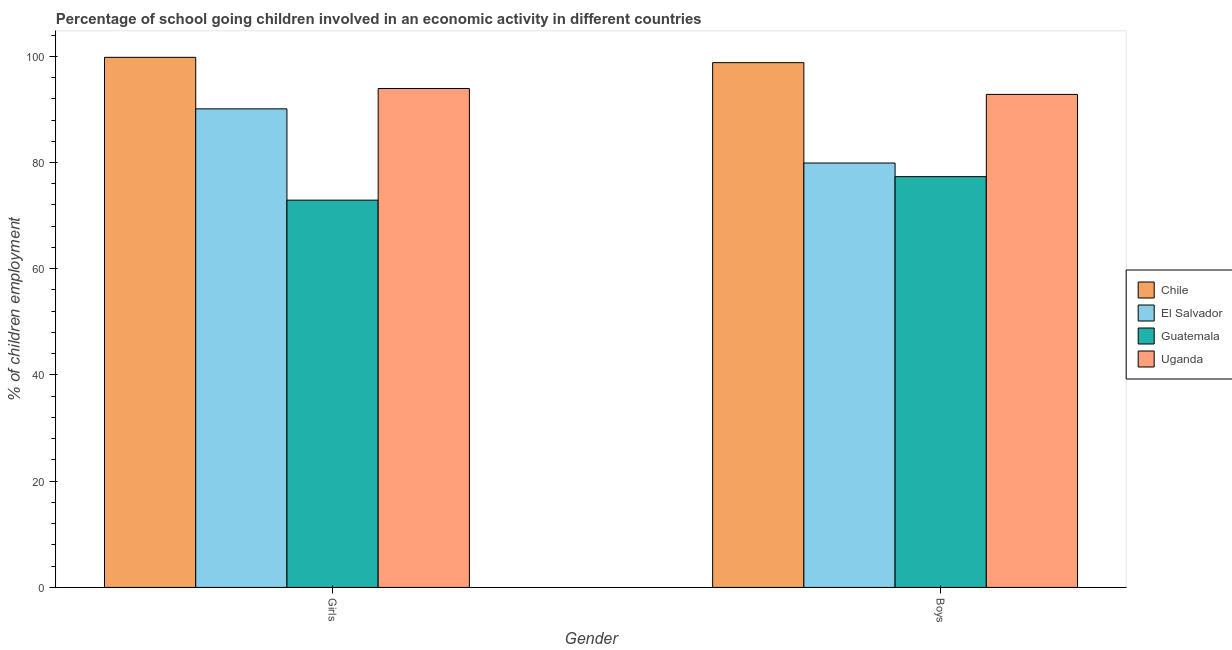How many different coloured bars are there?
Your answer should be compact. 4. How many groups of bars are there?
Make the answer very short. 2. How many bars are there on the 2nd tick from the left?
Keep it short and to the point. 4. How many bars are there on the 1st tick from the right?
Your answer should be compact. 4. What is the label of the 2nd group of bars from the left?
Ensure brevity in your answer.  Boys. What is the percentage of school going boys in El Salvador?
Make the answer very short. 79.9. Across all countries, what is the maximum percentage of school going girls?
Offer a terse response. 99.8. Across all countries, what is the minimum percentage of school going girls?
Give a very brief answer. 72.91. In which country was the percentage of school going girls minimum?
Provide a short and direct response. Guatemala. What is the total percentage of school going boys in the graph?
Provide a succinct answer. 348.86. What is the difference between the percentage of school going girls in Uganda and that in El Salvador?
Ensure brevity in your answer.  3.83. What is the difference between the percentage of school going boys in Uganda and the percentage of school going girls in El Salvador?
Keep it short and to the point. 2.72. What is the average percentage of school going girls per country?
Ensure brevity in your answer.  89.19. What is the difference between the percentage of school going boys and percentage of school going girls in El Salvador?
Make the answer very short. -10.2. In how many countries, is the percentage of school going boys greater than 12 %?
Offer a terse response. 4. What is the ratio of the percentage of school going boys in Guatemala to that in El Salvador?
Provide a short and direct response. 0.97. In how many countries, is the percentage of school going girls greater than the average percentage of school going girls taken over all countries?
Give a very brief answer. 3. What does the 1st bar from the right in Boys represents?
Your answer should be very brief. Uganda. Are all the bars in the graph horizontal?
Ensure brevity in your answer.  No. How many countries are there in the graph?
Keep it short and to the point. 4. Does the graph contain any zero values?
Keep it short and to the point. No. Does the graph contain grids?
Offer a terse response. No. Where does the legend appear in the graph?
Give a very brief answer. Center right. How many legend labels are there?
Offer a terse response. 4. What is the title of the graph?
Keep it short and to the point. Percentage of school going children involved in an economic activity in different countries. What is the label or title of the X-axis?
Give a very brief answer. Gender. What is the label or title of the Y-axis?
Provide a succinct answer. % of children employment. What is the % of children employment of Chile in Girls?
Offer a very short reply. 99.8. What is the % of children employment in El Salvador in Girls?
Provide a short and direct response. 90.1. What is the % of children employment of Guatemala in Girls?
Offer a terse response. 72.91. What is the % of children employment in Uganda in Girls?
Provide a succinct answer. 93.93. What is the % of children employment of Chile in Boys?
Offer a very short reply. 98.8. What is the % of children employment in El Salvador in Boys?
Your answer should be very brief. 79.9. What is the % of children employment in Guatemala in Boys?
Make the answer very short. 77.34. What is the % of children employment in Uganda in Boys?
Your response must be concise. 92.82. Across all Gender, what is the maximum % of children employment in Chile?
Provide a short and direct response. 99.8. Across all Gender, what is the maximum % of children employment of El Salvador?
Give a very brief answer. 90.1. Across all Gender, what is the maximum % of children employment of Guatemala?
Make the answer very short. 77.34. Across all Gender, what is the maximum % of children employment in Uganda?
Your answer should be very brief. 93.93. Across all Gender, what is the minimum % of children employment of Chile?
Ensure brevity in your answer.  98.8. Across all Gender, what is the minimum % of children employment in El Salvador?
Offer a terse response. 79.9. Across all Gender, what is the minimum % of children employment in Guatemala?
Offer a terse response. 72.91. Across all Gender, what is the minimum % of children employment of Uganda?
Give a very brief answer. 92.82. What is the total % of children employment of Chile in the graph?
Offer a very short reply. 198.6. What is the total % of children employment of El Salvador in the graph?
Give a very brief answer. 170. What is the total % of children employment of Guatemala in the graph?
Ensure brevity in your answer.  150.25. What is the total % of children employment in Uganda in the graph?
Ensure brevity in your answer.  186.75. What is the difference between the % of children employment of El Salvador in Girls and that in Boys?
Give a very brief answer. 10.2. What is the difference between the % of children employment of Guatemala in Girls and that in Boys?
Offer a very short reply. -4.43. What is the difference between the % of children employment in Uganda in Girls and that in Boys?
Keep it short and to the point. 1.11. What is the difference between the % of children employment in Chile in Girls and the % of children employment in El Salvador in Boys?
Offer a terse response. 19.9. What is the difference between the % of children employment of Chile in Girls and the % of children employment of Guatemala in Boys?
Provide a short and direct response. 22.46. What is the difference between the % of children employment in Chile in Girls and the % of children employment in Uganda in Boys?
Your answer should be compact. 6.98. What is the difference between the % of children employment of El Salvador in Girls and the % of children employment of Guatemala in Boys?
Keep it short and to the point. 12.76. What is the difference between the % of children employment in El Salvador in Girls and the % of children employment in Uganda in Boys?
Keep it short and to the point. -2.72. What is the difference between the % of children employment in Guatemala in Girls and the % of children employment in Uganda in Boys?
Give a very brief answer. -19.91. What is the average % of children employment of Chile per Gender?
Make the answer very short. 99.3. What is the average % of children employment in El Salvador per Gender?
Give a very brief answer. 85. What is the average % of children employment in Guatemala per Gender?
Give a very brief answer. 75.13. What is the average % of children employment in Uganda per Gender?
Ensure brevity in your answer.  93.37. What is the difference between the % of children employment of Chile and % of children employment of Guatemala in Girls?
Your answer should be compact. 26.89. What is the difference between the % of children employment in Chile and % of children employment in Uganda in Girls?
Provide a short and direct response. 5.87. What is the difference between the % of children employment of El Salvador and % of children employment of Guatemala in Girls?
Make the answer very short. 17.19. What is the difference between the % of children employment of El Salvador and % of children employment of Uganda in Girls?
Ensure brevity in your answer.  -3.83. What is the difference between the % of children employment in Guatemala and % of children employment in Uganda in Girls?
Provide a succinct answer. -21.02. What is the difference between the % of children employment in Chile and % of children employment in El Salvador in Boys?
Give a very brief answer. 18.9. What is the difference between the % of children employment of Chile and % of children employment of Guatemala in Boys?
Make the answer very short. 21.46. What is the difference between the % of children employment in Chile and % of children employment in Uganda in Boys?
Make the answer very short. 5.98. What is the difference between the % of children employment in El Salvador and % of children employment in Guatemala in Boys?
Make the answer very short. 2.56. What is the difference between the % of children employment in El Salvador and % of children employment in Uganda in Boys?
Ensure brevity in your answer.  -12.92. What is the difference between the % of children employment of Guatemala and % of children employment of Uganda in Boys?
Offer a terse response. -15.48. What is the ratio of the % of children employment of Chile in Girls to that in Boys?
Offer a terse response. 1.01. What is the ratio of the % of children employment of El Salvador in Girls to that in Boys?
Keep it short and to the point. 1.13. What is the ratio of the % of children employment of Guatemala in Girls to that in Boys?
Provide a succinct answer. 0.94. What is the ratio of the % of children employment of Uganda in Girls to that in Boys?
Offer a very short reply. 1.01. What is the difference between the highest and the second highest % of children employment in Chile?
Your response must be concise. 1. What is the difference between the highest and the second highest % of children employment in El Salvador?
Make the answer very short. 10.2. What is the difference between the highest and the second highest % of children employment in Guatemala?
Offer a very short reply. 4.43. What is the difference between the highest and the second highest % of children employment of Uganda?
Provide a short and direct response. 1.11. What is the difference between the highest and the lowest % of children employment of Chile?
Offer a terse response. 1. What is the difference between the highest and the lowest % of children employment in El Salvador?
Provide a short and direct response. 10.2. What is the difference between the highest and the lowest % of children employment of Guatemala?
Keep it short and to the point. 4.43. What is the difference between the highest and the lowest % of children employment in Uganda?
Make the answer very short. 1.11. 